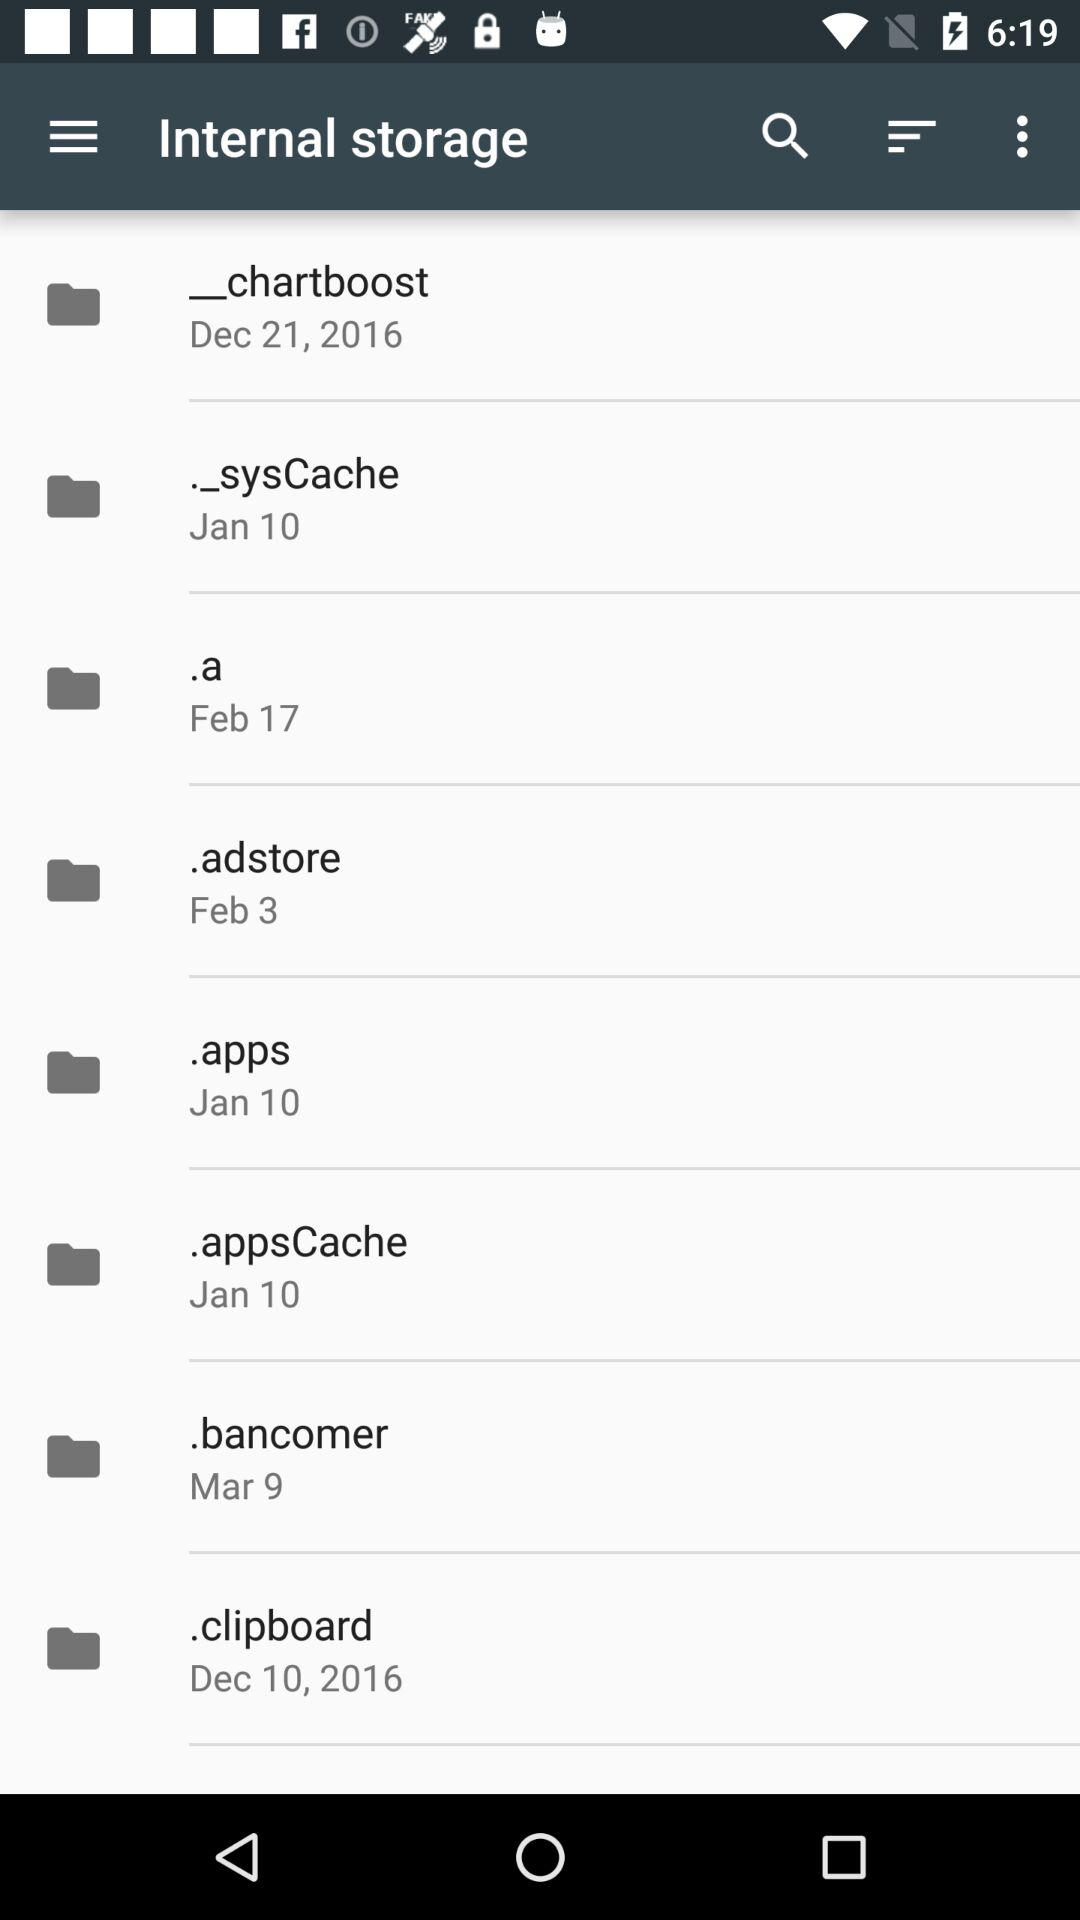What is the date mentioned for the folder ".clipboard"? The mentioned date is December 10, 2016. 